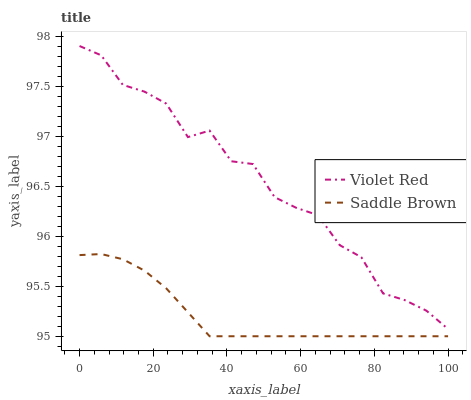Does Saddle Brown have the minimum area under the curve?
Answer yes or no. Yes. Does Violet Red have the maximum area under the curve?
Answer yes or no. Yes. Does Saddle Brown have the maximum area under the curve?
Answer yes or no. No. Is Saddle Brown the smoothest?
Answer yes or no. Yes. Is Violet Red the roughest?
Answer yes or no. Yes. Is Saddle Brown the roughest?
Answer yes or no. No. Does Saddle Brown have the lowest value?
Answer yes or no. Yes. Does Violet Red have the highest value?
Answer yes or no. Yes. Does Saddle Brown have the highest value?
Answer yes or no. No. Is Saddle Brown less than Violet Red?
Answer yes or no. Yes. Is Violet Red greater than Saddle Brown?
Answer yes or no. Yes. Does Saddle Brown intersect Violet Red?
Answer yes or no. No. 